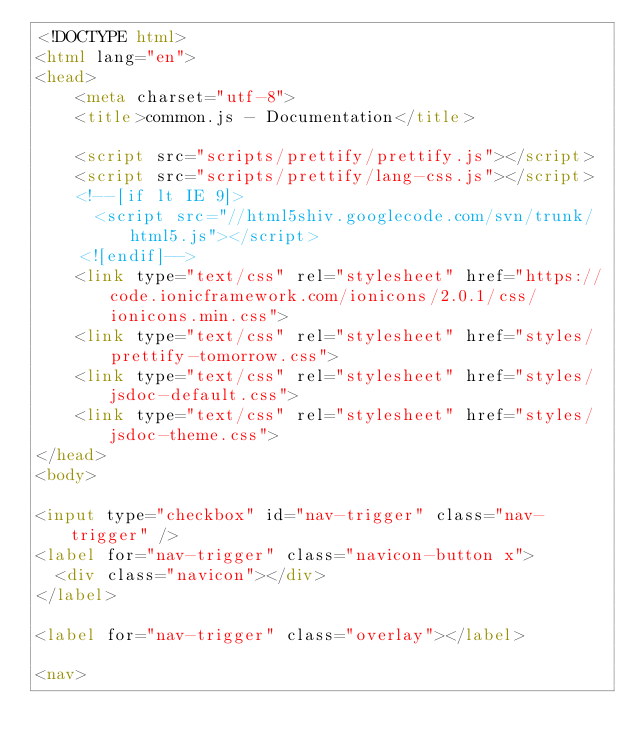Convert code to text. <code><loc_0><loc_0><loc_500><loc_500><_HTML_><!DOCTYPE html>
<html lang="en">
<head>
    <meta charset="utf-8">
    <title>common.js - Documentation</title>

    <script src="scripts/prettify/prettify.js"></script>
    <script src="scripts/prettify/lang-css.js"></script>
    <!--[if lt IE 9]>
      <script src="//html5shiv.googlecode.com/svn/trunk/html5.js"></script>
    <![endif]-->
    <link type="text/css" rel="stylesheet" href="https://code.ionicframework.com/ionicons/2.0.1/css/ionicons.min.css">
    <link type="text/css" rel="stylesheet" href="styles/prettify-tomorrow.css">
    <link type="text/css" rel="stylesheet" href="styles/jsdoc-default.css">
    <link type="text/css" rel="stylesheet" href="styles/jsdoc-theme.css">
</head>
<body>

<input type="checkbox" id="nav-trigger" class="nav-trigger" />
<label for="nav-trigger" class="navicon-button x">
  <div class="navicon"></div>
</label>

<label for="nav-trigger" class="overlay"></label>

<nav></code> 